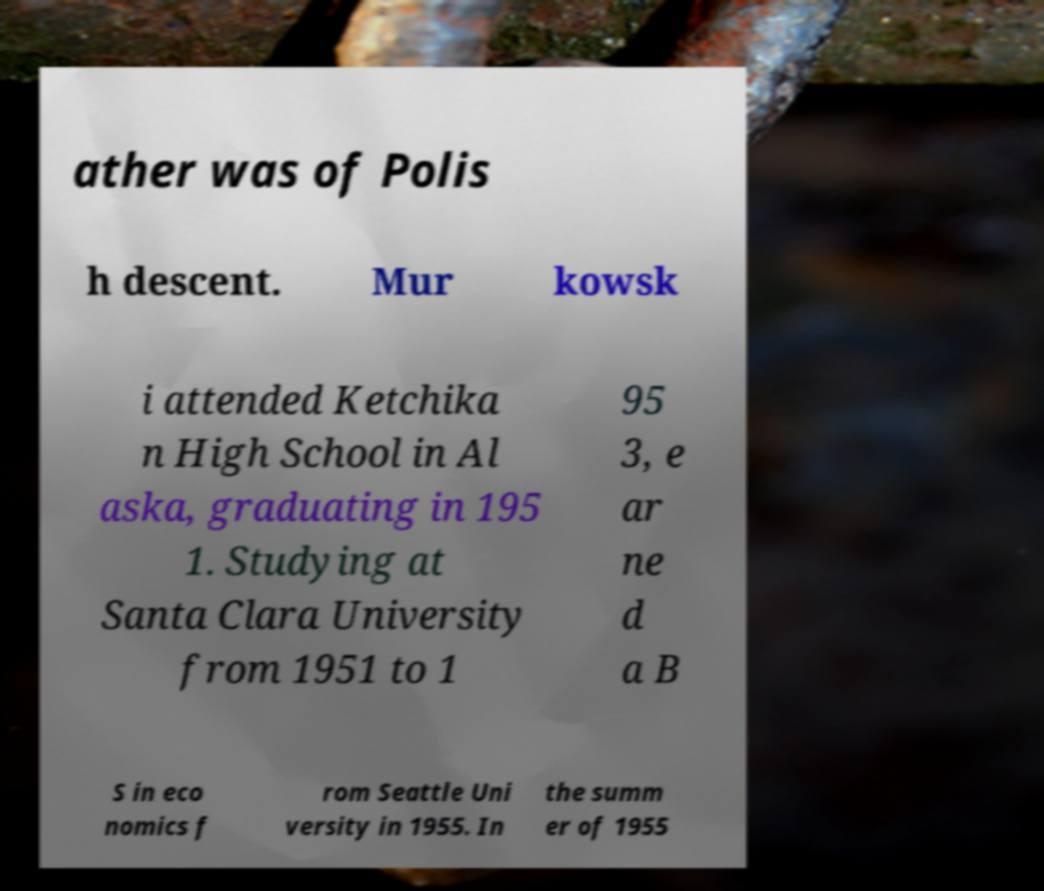Please read and relay the text visible in this image. What does it say? ather was of Polis h descent. Mur kowsk i attended Ketchika n High School in Al aska, graduating in 195 1. Studying at Santa Clara University from 1951 to 1 95 3, e ar ne d a B S in eco nomics f rom Seattle Uni versity in 1955. In the summ er of 1955 